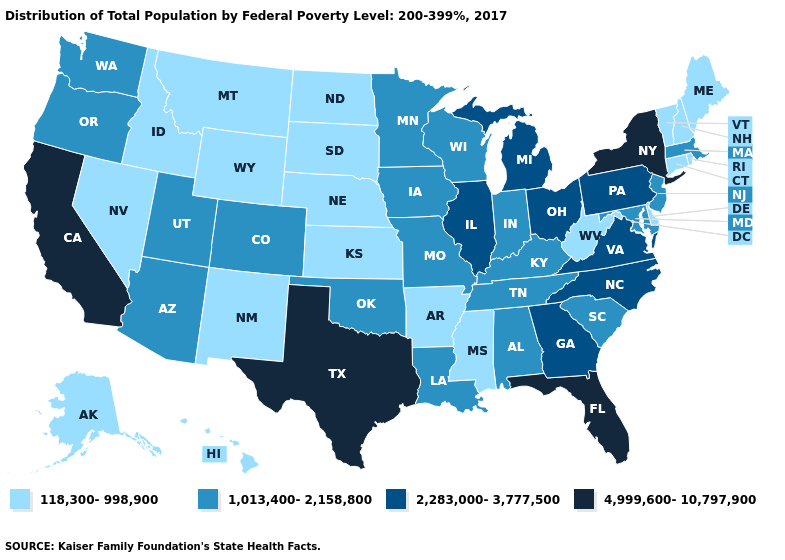What is the value of Washington?
Quick response, please. 1,013,400-2,158,800. What is the highest value in states that border Wyoming?
Quick response, please. 1,013,400-2,158,800. Which states hav the highest value in the South?
Short answer required. Florida, Texas. What is the value of North Carolina?
Quick response, please. 2,283,000-3,777,500. Does North Carolina have the lowest value in the USA?
Keep it brief. No. Which states have the lowest value in the USA?
Write a very short answer. Alaska, Arkansas, Connecticut, Delaware, Hawaii, Idaho, Kansas, Maine, Mississippi, Montana, Nebraska, Nevada, New Hampshire, New Mexico, North Dakota, Rhode Island, South Dakota, Vermont, West Virginia, Wyoming. Does Massachusetts have a higher value than West Virginia?
Keep it brief. Yes. Name the states that have a value in the range 1,013,400-2,158,800?
Concise answer only. Alabama, Arizona, Colorado, Indiana, Iowa, Kentucky, Louisiana, Maryland, Massachusetts, Minnesota, Missouri, New Jersey, Oklahoma, Oregon, South Carolina, Tennessee, Utah, Washington, Wisconsin. Name the states that have a value in the range 2,283,000-3,777,500?
Answer briefly. Georgia, Illinois, Michigan, North Carolina, Ohio, Pennsylvania, Virginia. What is the value of Iowa?
Quick response, please. 1,013,400-2,158,800. What is the lowest value in states that border Kentucky?
Concise answer only. 118,300-998,900. Which states have the lowest value in the Northeast?
Answer briefly. Connecticut, Maine, New Hampshire, Rhode Island, Vermont. Does the first symbol in the legend represent the smallest category?
Be succinct. Yes. Does the first symbol in the legend represent the smallest category?
Concise answer only. Yes. Among the states that border Arizona , which have the lowest value?
Give a very brief answer. Nevada, New Mexico. 